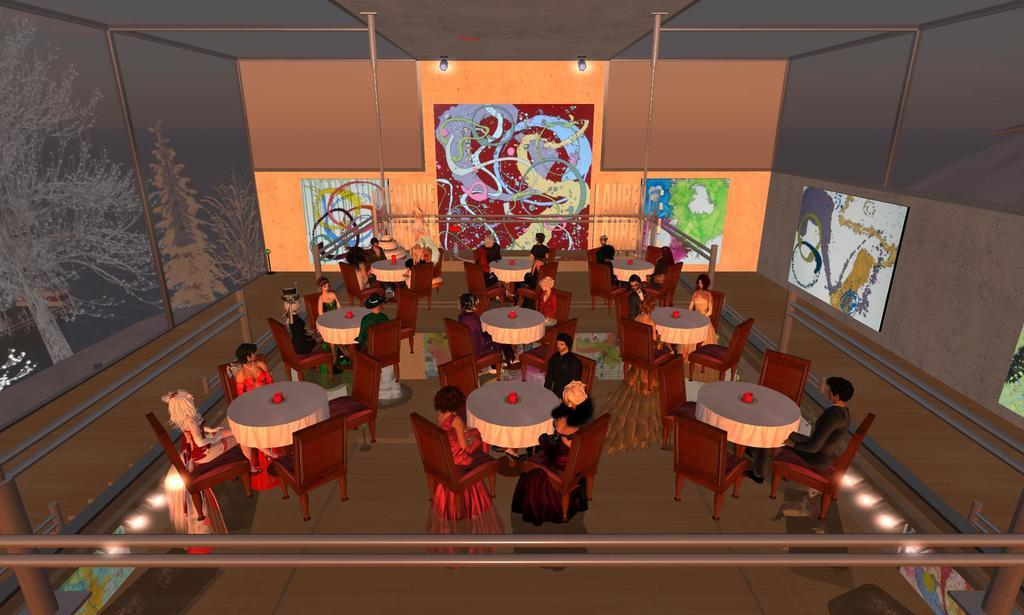What type of image is being described? The image is an animated picture. What can be seen on the walls in the image? Painted boards are on the walls. Are there any lighting features in the image? Yes, focusing lights are present. Can you describe the people in the image? There are people in the image, but their specific actions or appearances are not mentioned in the facts. What type of furniture is visible in the image? Chairs and tables are visible in the image. What is placed on the tables? Cloths are on the tables. Is there any artwork in the image? Yes, there is a painting on the wall. What is the income of the person who created the wool in the image? There is no mention of wool or the creator's income in the image or the provided facts. 